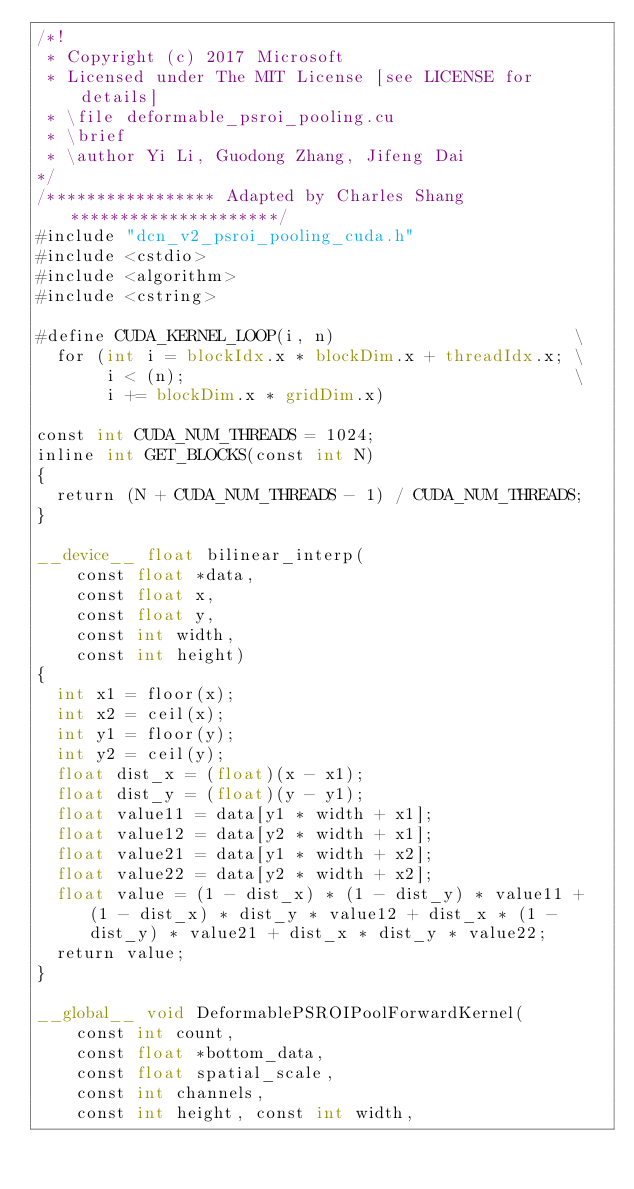<code> <loc_0><loc_0><loc_500><loc_500><_Cuda_>/*!
 * Copyright (c) 2017 Microsoft
 * Licensed under The MIT License [see LICENSE for details]
 * \file deformable_psroi_pooling.cu
 * \brief
 * \author Yi Li, Guodong Zhang, Jifeng Dai
*/
/***************** Adapted by Charles Shang *********************/
#include "dcn_v2_psroi_pooling_cuda.h"
#include <cstdio>
#include <algorithm>
#include <cstring>

#define CUDA_KERNEL_LOOP(i, n)                        \
  for (int i = blockIdx.x * blockDim.x + threadIdx.x; \
       i < (n);                                       \
       i += blockDim.x * gridDim.x)

const int CUDA_NUM_THREADS = 1024;
inline int GET_BLOCKS(const int N)
{
  return (N + CUDA_NUM_THREADS - 1) / CUDA_NUM_THREADS;
}

__device__ float bilinear_interp(
    const float *data,
    const float x,
    const float y,
    const int width,
    const int height)
{
  int x1 = floor(x);
  int x2 = ceil(x);
  int y1 = floor(y);
  int y2 = ceil(y);
  float dist_x = (float)(x - x1);
  float dist_y = (float)(y - y1);
  float value11 = data[y1 * width + x1];
  float value12 = data[y2 * width + x1];
  float value21 = data[y1 * width + x2];
  float value22 = data[y2 * width + x2];
  float value = (1 - dist_x) * (1 - dist_y) * value11 + (1 - dist_x) * dist_y * value12 + dist_x * (1 - dist_y) * value21 + dist_x * dist_y * value22;
  return value;
}

__global__ void DeformablePSROIPoolForwardKernel(
    const int count,
    const float *bottom_data,
    const float spatial_scale,
    const int channels,
    const int height, const int width,</code> 